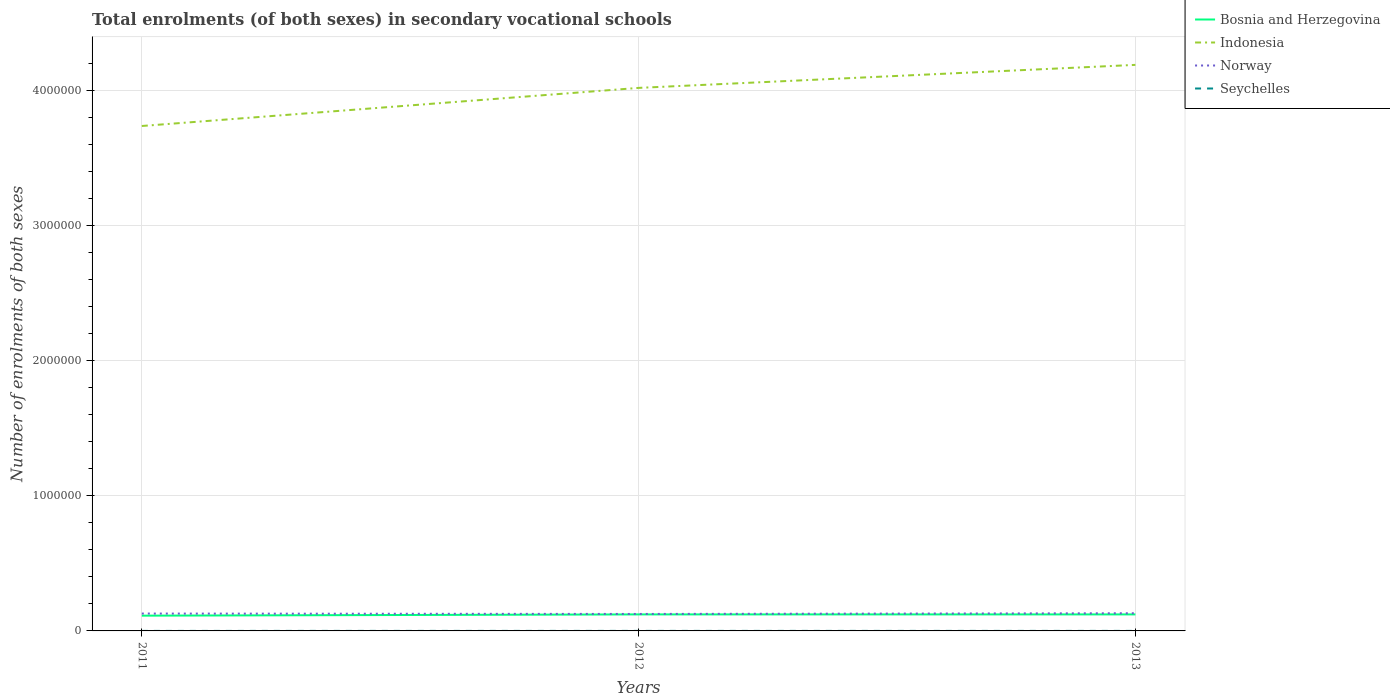How many different coloured lines are there?
Ensure brevity in your answer.  4. Across all years, what is the maximum number of enrolments in secondary schools in Norway?
Offer a very short reply. 1.26e+05. What is the total number of enrolments in secondary schools in Seychelles in the graph?
Keep it short and to the point. -86. What is the difference between the highest and the second highest number of enrolments in secondary schools in Indonesia?
Offer a terse response. 4.52e+05. What is the difference between the highest and the lowest number of enrolments in secondary schools in Indonesia?
Make the answer very short. 2. How many years are there in the graph?
Give a very brief answer. 3. What is the difference between two consecutive major ticks on the Y-axis?
Offer a terse response. 1.00e+06. Does the graph contain any zero values?
Offer a terse response. No. Where does the legend appear in the graph?
Give a very brief answer. Top right. How many legend labels are there?
Provide a succinct answer. 4. How are the legend labels stacked?
Keep it short and to the point. Vertical. What is the title of the graph?
Your answer should be compact. Total enrolments (of both sexes) in secondary vocational schools. Does "China" appear as one of the legend labels in the graph?
Offer a terse response. No. What is the label or title of the X-axis?
Your answer should be very brief. Years. What is the label or title of the Y-axis?
Provide a succinct answer. Number of enrolments of both sexes. What is the Number of enrolments of both sexes in Bosnia and Herzegovina in 2011?
Offer a very short reply. 1.13e+05. What is the Number of enrolments of both sexes in Indonesia in 2011?
Make the answer very short. 3.74e+06. What is the Number of enrolments of both sexes of Norway in 2011?
Make the answer very short. 1.29e+05. What is the Number of enrolments of both sexes in Seychelles in 2011?
Your answer should be very brief. 140. What is the Number of enrolments of both sexes of Bosnia and Herzegovina in 2012?
Give a very brief answer. 1.22e+05. What is the Number of enrolments of both sexes of Indonesia in 2012?
Keep it short and to the point. 4.02e+06. What is the Number of enrolments of both sexes in Norway in 2012?
Provide a succinct answer. 1.26e+05. What is the Number of enrolments of both sexes in Seychelles in 2012?
Offer a terse response. 266. What is the Number of enrolments of both sexes in Bosnia and Herzegovina in 2013?
Provide a succinct answer. 1.22e+05. What is the Number of enrolments of both sexes of Indonesia in 2013?
Provide a short and direct response. 4.19e+06. What is the Number of enrolments of both sexes of Norway in 2013?
Your response must be concise. 1.31e+05. What is the Number of enrolments of both sexes in Seychelles in 2013?
Provide a short and direct response. 226. Across all years, what is the maximum Number of enrolments of both sexes of Bosnia and Herzegovina?
Your answer should be very brief. 1.22e+05. Across all years, what is the maximum Number of enrolments of both sexes in Indonesia?
Provide a succinct answer. 4.19e+06. Across all years, what is the maximum Number of enrolments of both sexes of Norway?
Offer a very short reply. 1.31e+05. Across all years, what is the maximum Number of enrolments of both sexes of Seychelles?
Ensure brevity in your answer.  266. Across all years, what is the minimum Number of enrolments of both sexes of Bosnia and Herzegovina?
Provide a succinct answer. 1.13e+05. Across all years, what is the minimum Number of enrolments of both sexes of Indonesia?
Ensure brevity in your answer.  3.74e+06. Across all years, what is the minimum Number of enrolments of both sexes in Norway?
Your answer should be very brief. 1.26e+05. Across all years, what is the minimum Number of enrolments of both sexes in Seychelles?
Your answer should be very brief. 140. What is the total Number of enrolments of both sexes in Bosnia and Herzegovina in the graph?
Offer a terse response. 3.57e+05. What is the total Number of enrolments of both sexes of Indonesia in the graph?
Your answer should be very brief. 1.19e+07. What is the total Number of enrolments of both sexes of Norway in the graph?
Offer a very short reply. 3.85e+05. What is the total Number of enrolments of both sexes of Seychelles in the graph?
Give a very brief answer. 632. What is the difference between the Number of enrolments of both sexes of Bosnia and Herzegovina in 2011 and that in 2012?
Offer a very short reply. -9241. What is the difference between the Number of enrolments of both sexes of Indonesia in 2011 and that in 2012?
Offer a terse response. -2.82e+05. What is the difference between the Number of enrolments of both sexes of Norway in 2011 and that in 2012?
Your answer should be very brief. 3016. What is the difference between the Number of enrolments of both sexes of Seychelles in 2011 and that in 2012?
Make the answer very short. -126. What is the difference between the Number of enrolments of both sexes in Bosnia and Herzegovina in 2011 and that in 2013?
Give a very brief answer. -9311. What is the difference between the Number of enrolments of both sexes of Indonesia in 2011 and that in 2013?
Ensure brevity in your answer.  -4.52e+05. What is the difference between the Number of enrolments of both sexes of Norway in 2011 and that in 2013?
Your answer should be very brief. -2196. What is the difference between the Number of enrolments of both sexes of Seychelles in 2011 and that in 2013?
Provide a short and direct response. -86. What is the difference between the Number of enrolments of both sexes in Bosnia and Herzegovina in 2012 and that in 2013?
Your answer should be very brief. -70. What is the difference between the Number of enrolments of both sexes of Indonesia in 2012 and that in 2013?
Give a very brief answer. -1.70e+05. What is the difference between the Number of enrolments of both sexes in Norway in 2012 and that in 2013?
Give a very brief answer. -5212. What is the difference between the Number of enrolments of both sexes in Seychelles in 2012 and that in 2013?
Give a very brief answer. 40. What is the difference between the Number of enrolments of both sexes in Bosnia and Herzegovina in 2011 and the Number of enrolments of both sexes in Indonesia in 2012?
Make the answer very short. -3.91e+06. What is the difference between the Number of enrolments of both sexes of Bosnia and Herzegovina in 2011 and the Number of enrolments of both sexes of Norway in 2012?
Provide a succinct answer. -1.26e+04. What is the difference between the Number of enrolments of both sexes of Bosnia and Herzegovina in 2011 and the Number of enrolments of both sexes of Seychelles in 2012?
Your answer should be very brief. 1.13e+05. What is the difference between the Number of enrolments of both sexes in Indonesia in 2011 and the Number of enrolments of both sexes in Norway in 2012?
Keep it short and to the point. 3.61e+06. What is the difference between the Number of enrolments of both sexes in Indonesia in 2011 and the Number of enrolments of both sexes in Seychelles in 2012?
Offer a very short reply. 3.74e+06. What is the difference between the Number of enrolments of both sexes of Norway in 2011 and the Number of enrolments of both sexes of Seychelles in 2012?
Provide a succinct answer. 1.28e+05. What is the difference between the Number of enrolments of both sexes of Bosnia and Herzegovina in 2011 and the Number of enrolments of both sexes of Indonesia in 2013?
Give a very brief answer. -4.08e+06. What is the difference between the Number of enrolments of both sexes of Bosnia and Herzegovina in 2011 and the Number of enrolments of both sexes of Norway in 2013?
Offer a terse response. -1.78e+04. What is the difference between the Number of enrolments of both sexes in Bosnia and Herzegovina in 2011 and the Number of enrolments of both sexes in Seychelles in 2013?
Give a very brief answer. 1.13e+05. What is the difference between the Number of enrolments of both sexes of Indonesia in 2011 and the Number of enrolments of both sexes of Norway in 2013?
Offer a very short reply. 3.61e+06. What is the difference between the Number of enrolments of both sexes of Indonesia in 2011 and the Number of enrolments of both sexes of Seychelles in 2013?
Offer a very short reply. 3.74e+06. What is the difference between the Number of enrolments of both sexes in Norway in 2011 and the Number of enrolments of both sexes in Seychelles in 2013?
Make the answer very short. 1.28e+05. What is the difference between the Number of enrolments of both sexes in Bosnia and Herzegovina in 2012 and the Number of enrolments of both sexes in Indonesia in 2013?
Your answer should be compact. -4.07e+06. What is the difference between the Number of enrolments of both sexes in Bosnia and Herzegovina in 2012 and the Number of enrolments of both sexes in Norway in 2013?
Your answer should be very brief. -8586. What is the difference between the Number of enrolments of both sexes in Bosnia and Herzegovina in 2012 and the Number of enrolments of both sexes in Seychelles in 2013?
Give a very brief answer. 1.22e+05. What is the difference between the Number of enrolments of both sexes in Indonesia in 2012 and the Number of enrolments of both sexes in Norway in 2013?
Provide a succinct answer. 3.89e+06. What is the difference between the Number of enrolments of both sexes of Indonesia in 2012 and the Number of enrolments of both sexes of Seychelles in 2013?
Your answer should be very brief. 4.02e+06. What is the difference between the Number of enrolments of both sexes of Norway in 2012 and the Number of enrolments of both sexes of Seychelles in 2013?
Offer a very short reply. 1.25e+05. What is the average Number of enrolments of both sexes in Bosnia and Herzegovina per year?
Your response must be concise. 1.19e+05. What is the average Number of enrolments of both sexes of Indonesia per year?
Offer a terse response. 3.98e+06. What is the average Number of enrolments of both sexes in Norway per year?
Your response must be concise. 1.28e+05. What is the average Number of enrolments of both sexes of Seychelles per year?
Your answer should be very brief. 210.67. In the year 2011, what is the difference between the Number of enrolments of both sexes of Bosnia and Herzegovina and Number of enrolments of both sexes of Indonesia?
Offer a very short reply. -3.62e+06. In the year 2011, what is the difference between the Number of enrolments of both sexes of Bosnia and Herzegovina and Number of enrolments of both sexes of Norway?
Offer a very short reply. -1.56e+04. In the year 2011, what is the difference between the Number of enrolments of both sexes in Bosnia and Herzegovina and Number of enrolments of both sexes in Seychelles?
Offer a terse response. 1.13e+05. In the year 2011, what is the difference between the Number of enrolments of both sexes in Indonesia and Number of enrolments of both sexes in Norway?
Offer a very short reply. 3.61e+06. In the year 2011, what is the difference between the Number of enrolments of both sexes of Indonesia and Number of enrolments of both sexes of Seychelles?
Offer a terse response. 3.74e+06. In the year 2011, what is the difference between the Number of enrolments of both sexes of Norway and Number of enrolments of both sexes of Seychelles?
Provide a succinct answer. 1.28e+05. In the year 2012, what is the difference between the Number of enrolments of both sexes of Bosnia and Herzegovina and Number of enrolments of both sexes of Indonesia?
Your answer should be very brief. -3.90e+06. In the year 2012, what is the difference between the Number of enrolments of both sexes of Bosnia and Herzegovina and Number of enrolments of both sexes of Norway?
Give a very brief answer. -3374. In the year 2012, what is the difference between the Number of enrolments of both sexes of Bosnia and Herzegovina and Number of enrolments of both sexes of Seychelles?
Ensure brevity in your answer.  1.22e+05. In the year 2012, what is the difference between the Number of enrolments of both sexes in Indonesia and Number of enrolments of both sexes in Norway?
Offer a very short reply. 3.89e+06. In the year 2012, what is the difference between the Number of enrolments of both sexes of Indonesia and Number of enrolments of both sexes of Seychelles?
Provide a succinct answer. 4.02e+06. In the year 2012, what is the difference between the Number of enrolments of both sexes of Norway and Number of enrolments of both sexes of Seychelles?
Ensure brevity in your answer.  1.25e+05. In the year 2013, what is the difference between the Number of enrolments of both sexes of Bosnia and Herzegovina and Number of enrolments of both sexes of Indonesia?
Make the answer very short. -4.07e+06. In the year 2013, what is the difference between the Number of enrolments of both sexes of Bosnia and Herzegovina and Number of enrolments of both sexes of Norway?
Offer a terse response. -8516. In the year 2013, what is the difference between the Number of enrolments of both sexes in Bosnia and Herzegovina and Number of enrolments of both sexes in Seychelles?
Provide a short and direct response. 1.22e+05. In the year 2013, what is the difference between the Number of enrolments of both sexes in Indonesia and Number of enrolments of both sexes in Norway?
Provide a succinct answer. 4.06e+06. In the year 2013, what is the difference between the Number of enrolments of both sexes in Indonesia and Number of enrolments of both sexes in Seychelles?
Ensure brevity in your answer.  4.19e+06. In the year 2013, what is the difference between the Number of enrolments of both sexes in Norway and Number of enrolments of both sexes in Seychelles?
Make the answer very short. 1.31e+05. What is the ratio of the Number of enrolments of both sexes of Bosnia and Herzegovina in 2011 to that in 2012?
Offer a very short reply. 0.92. What is the ratio of the Number of enrolments of both sexes of Indonesia in 2011 to that in 2012?
Offer a terse response. 0.93. What is the ratio of the Number of enrolments of both sexes of Seychelles in 2011 to that in 2012?
Provide a succinct answer. 0.53. What is the ratio of the Number of enrolments of both sexes of Bosnia and Herzegovina in 2011 to that in 2013?
Your answer should be very brief. 0.92. What is the ratio of the Number of enrolments of both sexes of Indonesia in 2011 to that in 2013?
Make the answer very short. 0.89. What is the ratio of the Number of enrolments of both sexes in Norway in 2011 to that in 2013?
Your response must be concise. 0.98. What is the ratio of the Number of enrolments of both sexes of Seychelles in 2011 to that in 2013?
Give a very brief answer. 0.62. What is the ratio of the Number of enrolments of both sexes in Bosnia and Herzegovina in 2012 to that in 2013?
Offer a terse response. 1. What is the ratio of the Number of enrolments of both sexes of Indonesia in 2012 to that in 2013?
Ensure brevity in your answer.  0.96. What is the ratio of the Number of enrolments of both sexes in Norway in 2012 to that in 2013?
Offer a terse response. 0.96. What is the ratio of the Number of enrolments of both sexes of Seychelles in 2012 to that in 2013?
Keep it short and to the point. 1.18. What is the difference between the highest and the second highest Number of enrolments of both sexes in Bosnia and Herzegovina?
Offer a terse response. 70. What is the difference between the highest and the second highest Number of enrolments of both sexes in Indonesia?
Offer a very short reply. 1.70e+05. What is the difference between the highest and the second highest Number of enrolments of both sexes of Norway?
Your response must be concise. 2196. What is the difference between the highest and the lowest Number of enrolments of both sexes in Bosnia and Herzegovina?
Provide a succinct answer. 9311. What is the difference between the highest and the lowest Number of enrolments of both sexes in Indonesia?
Keep it short and to the point. 4.52e+05. What is the difference between the highest and the lowest Number of enrolments of both sexes in Norway?
Your answer should be very brief. 5212. What is the difference between the highest and the lowest Number of enrolments of both sexes of Seychelles?
Keep it short and to the point. 126. 